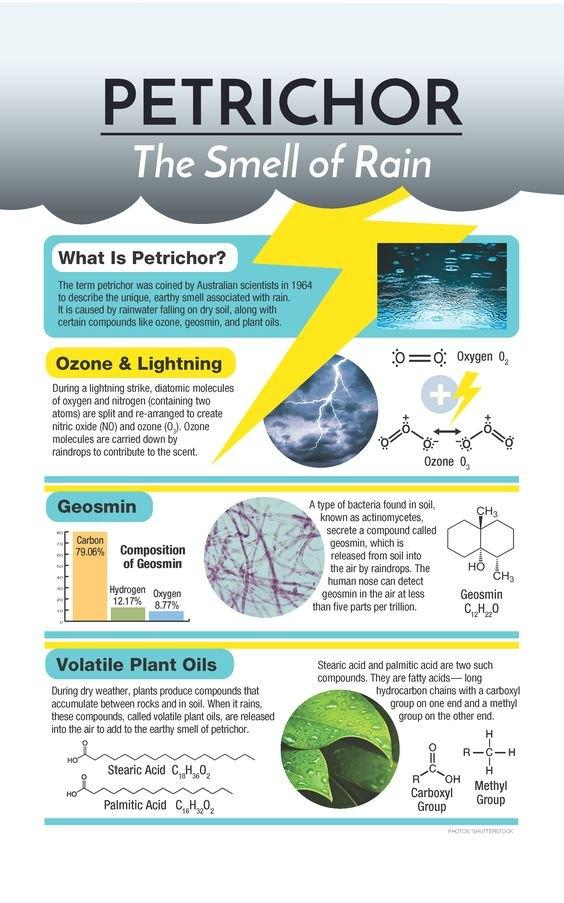Point out several critical features in this image. The chemical compound Geosmin is composed of 20.94% hydrogen and oxygen. Geosmin consists of 87.83% carbon and oxygen. 